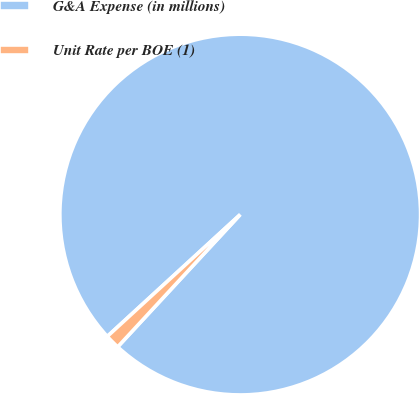<chart> <loc_0><loc_0><loc_500><loc_500><pie_chart><fcel>G&A Expense (in millions)<fcel>Unit Rate per BOE (1)<nl><fcel>98.7%<fcel>1.3%<nl></chart> 